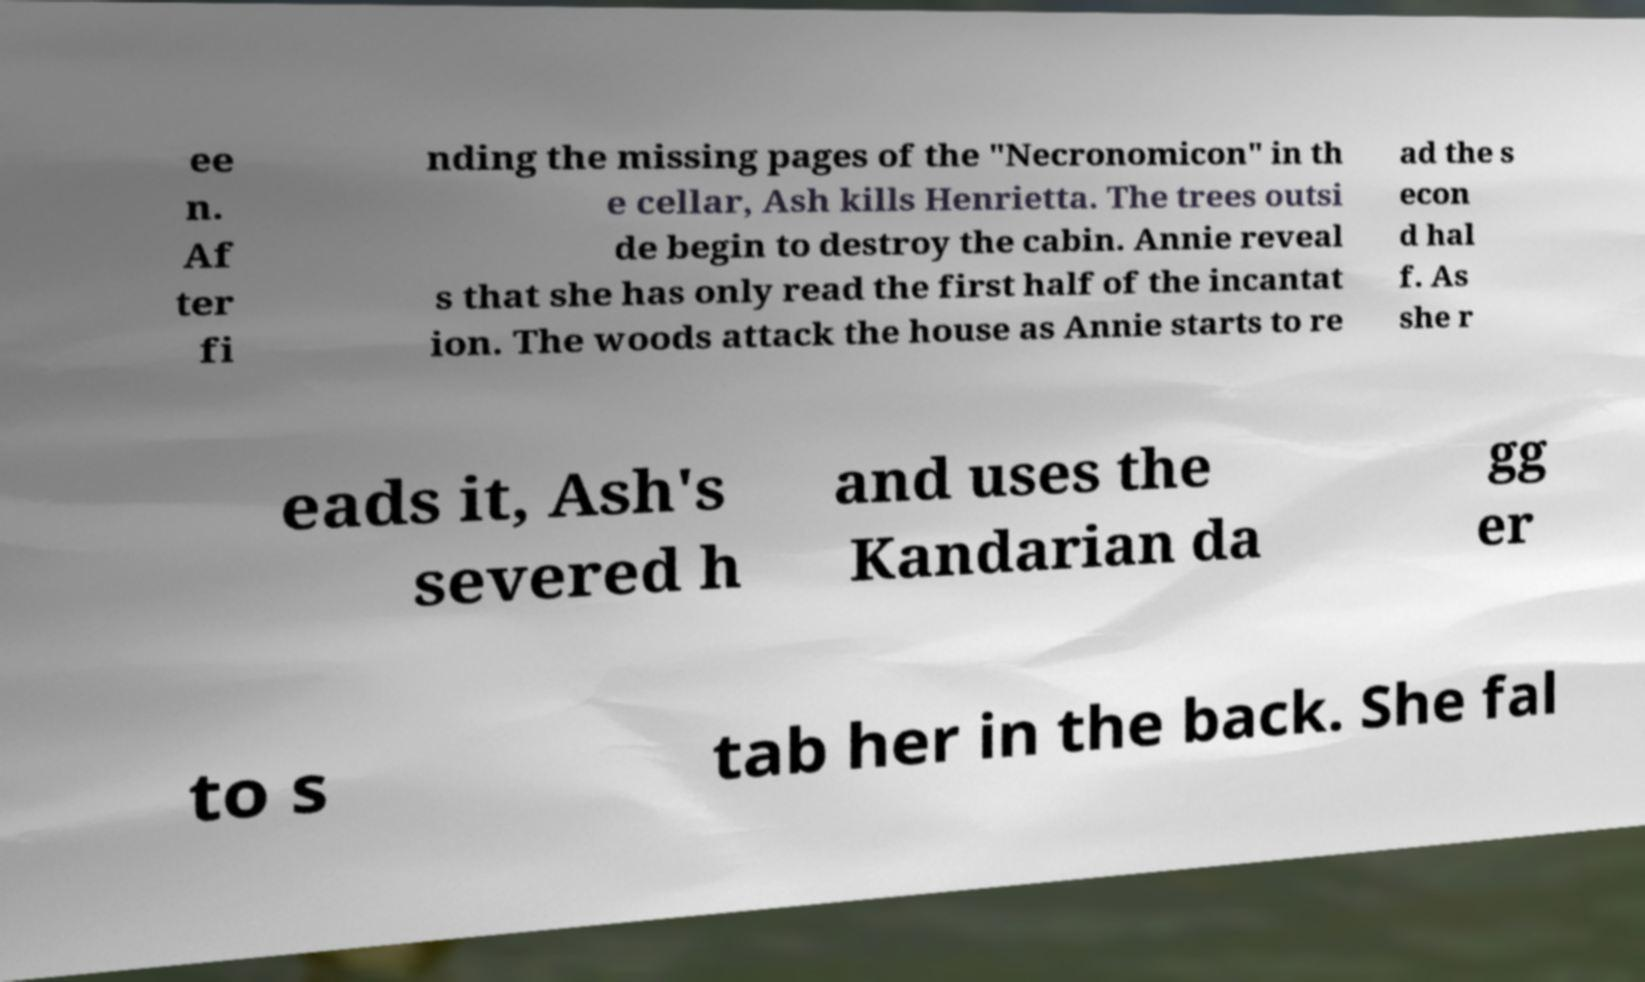I need the written content from this picture converted into text. Can you do that? ee n. Af ter fi nding the missing pages of the "Necronomicon" in th e cellar, Ash kills Henrietta. The trees outsi de begin to destroy the cabin. Annie reveal s that she has only read the first half of the incantat ion. The woods attack the house as Annie starts to re ad the s econ d hal f. As she r eads it, Ash's severed h and uses the Kandarian da gg er to s tab her in the back. She fal 